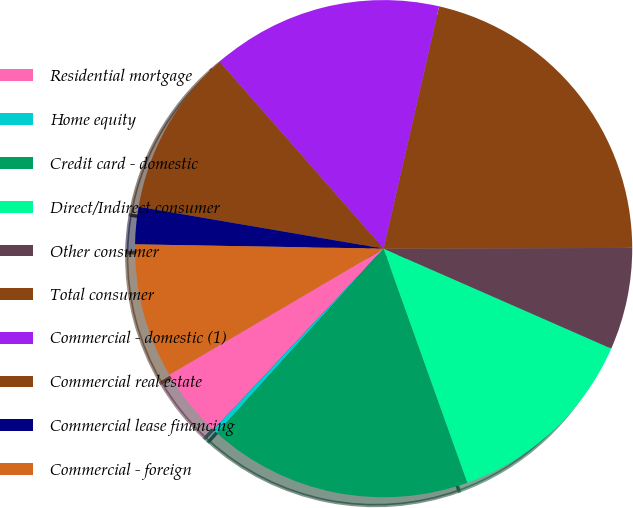Convert chart. <chart><loc_0><loc_0><loc_500><loc_500><pie_chart><fcel>Residential mortgage<fcel>Home equity<fcel>Credit card - domestic<fcel>Direct/Indirect consumer<fcel>Other consumer<fcel>Total consumer<fcel>Commercial - domestic (1)<fcel>Commercial real estate<fcel>Commercial lease financing<fcel>Commercial - foreign<nl><fcel>4.53%<fcel>0.32%<fcel>17.16%<fcel>12.95%<fcel>6.63%<fcel>21.37%<fcel>15.05%<fcel>10.84%<fcel>2.42%<fcel>8.74%<nl></chart> 